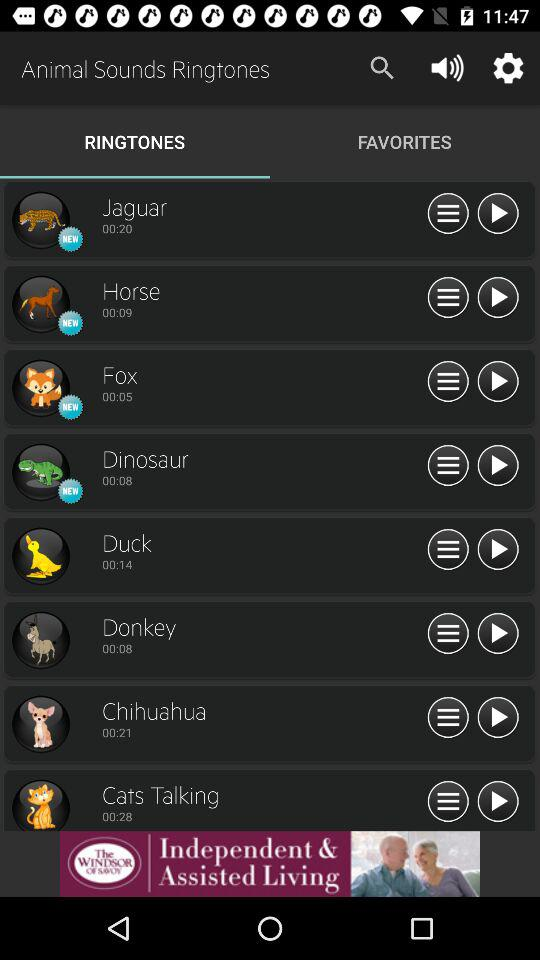Which tab am I now on? You are now on the "RINGTONES" tab. 